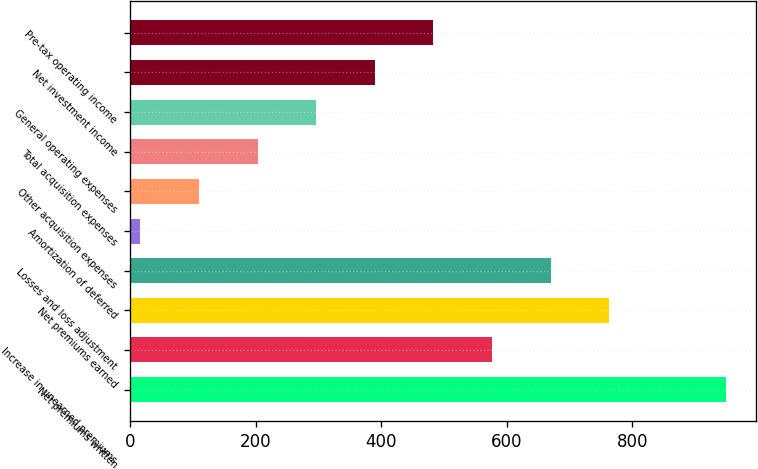Convert chart to OTSL. <chart><loc_0><loc_0><loc_500><loc_500><bar_chart><fcel>Net premiums written<fcel>Increase in unearned premiums<fcel>Net premiums earned<fcel>Losses and loss adjustment<fcel>Amortization of deferred<fcel>Other acquisition expenses<fcel>Total acquisition expenses<fcel>General operating expenses<fcel>Net investment income<fcel>Pre-tax operating income<nl><fcel>950<fcel>576.4<fcel>763.2<fcel>669.8<fcel>16<fcel>109.4<fcel>202.8<fcel>296.2<fcel>389.6<fcel>483<nl></chart> 